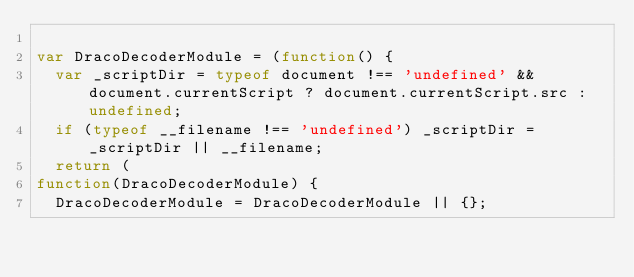<code> <loc_0><loc_0><loc_500><loc_500><_JavaScript_>
var DracoDecoderModule = (function() {
  var _scriptDir = typeof document !== 'undefined' && document.currentScript ? document.currentScript.src : undefined;
  if (typeof __filename !== 'undefined') _scriptDir = _scriptDir || __filename;
  return (
function(DracoDecoderModule) {
  DracoDecoderModule = DracoDecoderModule || {};
</code> 